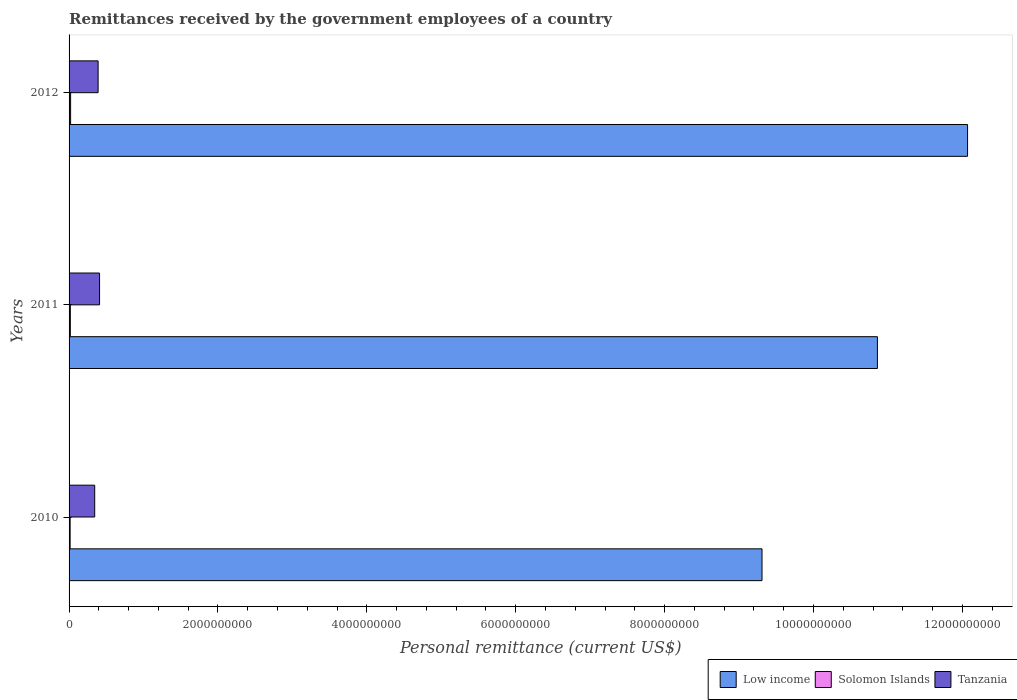How many different coloured bars are there?
Your answer should be very brief. 3. How many groups of bars are there?
Your response must be concise. 3. Are the number of bars on each tick of the Y-axis equal?
Keep it short and to the point. Yes. How many bars are there on the 2nd tick from the top?
Your answer should be compact. 3. How many bars are there on the 3rd tick from the bottom?
Give a very brief answer. 3. What is the label of the 3rd group of bars from the top?
Your response must be concise. 2010. What is the remittances received by the government employees in Low income in 2012?
Make the answer very short. 1.21e+1. Across all years, what is the maximum remittances received by the government employees in Solomon Islands?
Provide a succinct answer. 2.07e+07. Across all years, what is the minimum remittances received by the government employees in Low income?
Offer a terse response. 9.31e+09. In which year was the remittances received by the government employees in Low income maximum?
Provide a succinct answer. 2012. In which year was the remittances received by the government employees in Tanzania minimum?
Your answer should be compact. 2010. What is the total remittances received by the government employees in Tanzania in the graph?
Offer a very short reply. 1.14e+09. What is the difference between the remittances received by the government employees in Tanzania in 2010 and that in 2011?
Offer a terse response. -6.53e+07. What is the difference between the remittances received by the government employees in Low income in 2011 and the remittances received by the government employees in Solomon Islands in 2012?
Provide a short and direct response. 1.08e+1. What is the average remittances received by the government employees in Solomon Islands per year?
Your answer should be very brief. 1.73e+07. In the year 2010, what is the difference between the remittances received by the government employees in Solomon Islands and remittances received by the government employees in Low income?
Offer a terse response. -9.29e+09. In how many years, is the remittances received by the government employees in Tanzania greater than 9200000000 US$?
Ensure brevity in your answer.  0. What is the ratio of the remittances received by the government employees in Low income in 2010 to that in 2011?
Ensure brevity in your answer.  0.86. Is the difference between the remittances received by the government employees in Solomon Islands in 2010 and 2011 greater than the difference between the remittances received by the government employees in Low income in 2010 and 2011?
Give a very brief answer. Yes. What is the difference between the highest and the second highest remittances received by the government employees in Solomon Islands?
Your answer should be very brief. 3.79e+06. What is the difference between the highest and the lowest remittances received by the government employees in Low income?
Give a very brief answer. 2.76e+09. In how many years, is the remittances received by the government employees in Tanzania greater than the average remittances received by the government employees in Tanzania taken over all years?
Make the answer very short. 2. Is the sum of the remittances received by the government employees in Low income in 2010 and 2011 greater than the maximum remittances received by the government employees in Tanzania across all years?
Provide a short and direct response. Yes. What does the 1st bar from the top in 2012 represents?
Give a very brief answer. Tanzania. Are all the bars in the graph horizontal?
Make the answer very short. Yes. How many years are there in the graph?
Ensure brevity in your answer.  3. Are the values on the major ticks of X-axis written in scientific E-notation?
Keep it short and to the point. No. Does the graph contain grids?
Give a very brief answer. No. How are the legend labels stacked?
Provide a short and direct response. Horizontal. What is the title of the graph?
Your response must be concise. Remittances received by the government employees of a country. What is the label or title of the X-axis?
Provide a short and direct response. Personal remittance (current US$). What is the Personal remittance (current US$) in Low income in 2010?
Provide a short and direct response. 9.31e+09. What is the Personal remittance (current US$) of Solomon Islands in 2010?
Give a very brief answer. 1.43e+07. What is the Personal remittance (current US$) of Tanzania in 2010?
Keep it short and to the point. 3.44e+08. What is the Personal remittance (current US$) in Low income in 2011?
Give a very brief answer. 1.09e+1. What is the Personal remittance (current US$) of Solomon Islands in 2011?
Ensure brevity in your answer.  1.69e+07. What is the Personal remittance (current US$) of Tanzania in 2011?
Your answer should be compact. 4.10e+08. What is the Personal remittance (current US$) in Low income in 2012?
Offer a terse response. 1.21e+1. What is the Personal remittance (current US$) in Solomon Islands in 2012?
Offer a terse response. 2.07e+07. What is the Personal remittance (current US$) of Tanzania in 2012?
Provide a succinct answer. 3.90e+08. Across all years, what is the maximum Personal remittance (current US$) of Low income?
Offer a very short reply. 1.21e+1. Across all years, what is the maximum Personal remittance (current US$) of Solomon Islands?
Give a very brief answer. 2.07e+07. Across all years, what is the maximum Personal remittance (current US$) in Tanzania?
Make the answer very short. 4.10e+08. Across all years, what is the minimum Personal remittance (current US$) in Low income?
Your response must be concise. 9.31e+09. Across all years, what is the minimum Personal remittance (current US$) of Solomon Islands?
Your answer should be very brief. 1.43e+07. Across all years, what is the minimum Personal remittance (current US$) in Tanzania?
Your answer should be compact. 3.44e+08. What is the total Personal remittance (current US$) in Low income in the graph?
Make the answer very short. 3.22e+1. What is the total Personal remittance (current US$) of Solomon Islands in the graph?
Your answer should be compact. 5.19e+07. What is the total Personal remittance (current US$) in Tanzania in the graph?
Provide a short and direct response. 1.14e+09. What is the difference between the Personal remittance (current US$) in Low income in 2010 and that in 2011?
Offer a terse response. -1.55e+09. What is the difference between the Personal remittance (current US$) of Solomon Islands in 2010 and that in 2011?
Ensure brevity in your answer.  -2.65e+06. What is the difference between the Personal remittance (current US$) of Tanzania in 2010 and that in 2011?
Provide a succinct answer. -6.53e+07. What is the difference between the Personal remittance (current US$) of Low income in 2010 and that in 2012?
Ensure brevity in your answer.  -2.76e+09. What is the difference between the Personal remittance (current US$) in Solomon Islands in 2010 and that in 2012?
Ensure brevity in your answer.  -6.44e+06. What is the difference between the Personal remittance (current US$) of Tanzania in 2010 and that in 2012?
Keep it short and to the point. -4.59e+07. What is the difference between the Personal remittance (current US$) of Low income in 2011 and that in 2012?
Your response must be concise. -1.21e+09. What is the difference between the Personal remittance (current US$) of Solomon Islands in 2011 and that in 2012?
Offer a very short reply. -3.79e+06. What is the difference between the Personal remittance (current US$) of Tanzania in 2011 and that in 2012?
Keep it short and to the point. 1.94e+07. What is the difference between the Personal remittance (current US$) of Low income in 2010 and the Personal remittance (current US$) of Solomon Islands in 2011?
Provide a short and direct response. 9.29e+09. What is the difference between the Personal remittance (current US$) of Low income in 2010 and the Personal remittance (current US$) of Tanzania in 2011?
Your answer should be compact. 8.90e+09. What is the difference between the Personal remittance (current US$) of Solomon Islands in 2010 and the Personal remittance (current US$) of Tanzania in 2011?
Offer a very short reply. -3.95e+08. What is the difference between the Personal remittance (current US$) of Low income in 2010 and the Personal remittance (current US$) of Solomon Islands in 2012?
Ensure brevity in your answer.  9.29e+09. What is the difference between the Personal remittance (current US$) of Low income in 2010 and the Personal remittance (current US$) of Tanzania in 2012?
Provide a short and direct response. 8.92e+09. What is the difference between the Personal remittance (current US$) of Solomon Islands in 2010 and the Personal remittance (current US$) of Tanzania in 2012?
Provide a short and direct response. -3.76e+08. What is the difference between the Personal remittance (current US$) in Low income in 2011 and the Personal remittance (current US$) in Solomon Islands in 2012?
Make the answer very short. 1.08e+1. What is the difference between the Personal remittance (current US$) in Low income in 2011 and the Personal remittance (current US$) in Tanzania in 2012?
Your response must be concise. 1.05e+1. What is the difference between the Personal remittance (current US$) in Solomon Islands in 2011 and the Personal remittance (current US$) in Tanzania in 2012?
Offer a very short reply. -3.73e+08. What is the average Personal remittance (current US$) in Low income per year?
Offer a terse response. 1.07e+1. What is the average Personal remittance (current US$) in Solomon Islands per year?
Offer a terse response. 1.73e+07. What is the average Personal remittance (current US$) of Tanzania per year?
Provide a succinct answer. 3.81e+08. In the year 2010, what is the difference between the Personal remittance (current US$) in Low income and Personal remittance (current US$) in Solomon Islands?
Provide a succinct answer. 9.29e+09. In the year 2010, what is the difference between the Personal remittance (current US$) in Low income and Personal remittance (current US$) in Tanzania?
Your answer should be very brief. 8.96e+09. In the year 2010, what is the difference between the Personal remittance (current US$) in Solomon Islands and Personal remittance (current US$) in Tanzania?
Your answer should be compact. -3.30e+08. In the year 2011, what is the difference between the Personal remittance (current US$) of Low income and Personal remittance (current US$) of Solomon Islands?
Keep it short and to the point. 1.08e+1. In the year 2011, what is the difference between the Personal remittance (current US$) of Low income and Personal remittance (current US$) of Tanzania?
Give a very brief answer. 1.04e+1. In the year 2011, what is the difference between the Personal remittance (current US$) in Solomon Islands and Personal remittance (current US$) in Tanzania?
Your response must be concise. -3.93e+08. In the year 2012, what is the difference between the Personal remittance (current US$) in Low income and Personal remittance (current US$) in Solomon Islands?
Keep it short and to the point. 1.20e+1. In the year 2012, what is the difference between the Personal remittance (current US$) in Low income and Personal remittance (current US$) in Tanzania?
Offer a very short reply. 1.17e+1. In the year 2012, what is the difference between the Personal remittance (current US$) of Solomon Islands and Personal remittance (current US$) of Tanzania?
Ensure brevity in your answer.  -3.69e+08. What is the ratio of the Personal remittance (current US$) of Low income in 2010 to that in 2011?
Provide a succinct answer. 0.86. What is the ratio of the Personal remittance (current US$) in Solomon Islands in 2010 to that in 2011?
Give a very brief answer. 0.84. What is the ratio of the Personal remittance (current US$) of Tanzania in 2010 to that in 2011?
Offer a very short reply. 0.84. What is the ratio of the Personal remittance (current US$) in Low income in 2010 to that in 2012?
Your response must be concise. 0.77. What is the ratio of the Personal remittance (current US$) of Solomon Islands in 2010 to that in 2012?
Your answer should be very brief. 0.69. What is the ratio of the Personal remittance (current US$) of Tanzania in 2010 to that in 2012?
Your response must be concise. 0.88. What is the ratio of the Personal remittance (current US$) of Low income in 2011 to that in 2012?
Keep it short and to the point. 0.9. What is the ratio of the Personal remittance (current US$) of Solomon Islands in 2011 to that in 2012?
Ensure brevity in your answer.  0.82. What is the ratio of the Personal remittance (current US$) in Tanzania in 2011 to that in 2012?
Give a very brief answer. 1.05. What is the difference between the highest and the second highest Personal remittance (current US$) of Low income?
Keep it short and to the point. 1.21e+09. What is the difference between the highest and the second highest Personal remittance (current US$) of Solomon Islands?
Make the answer very short. 3.79e+06. What is the difference between the highest and the second highest Personal remittance (current US$) of Tanzania?
Your response must be concise. 1.94e+07. What is the difference between the highest and the lowest Personal remittance (current US$) in Low income?
Your answer should be compact. 2.76e+09. What is the difference between the highest and the lowest Personal remittance (current US$) in Solomon Islands?
Your answer should be compact. 6.44e+06. What is the difference between the highest and the lowest Personal remittance (current US$) in Tanzania?
Keep it short and to the point. 6.53e+07. 